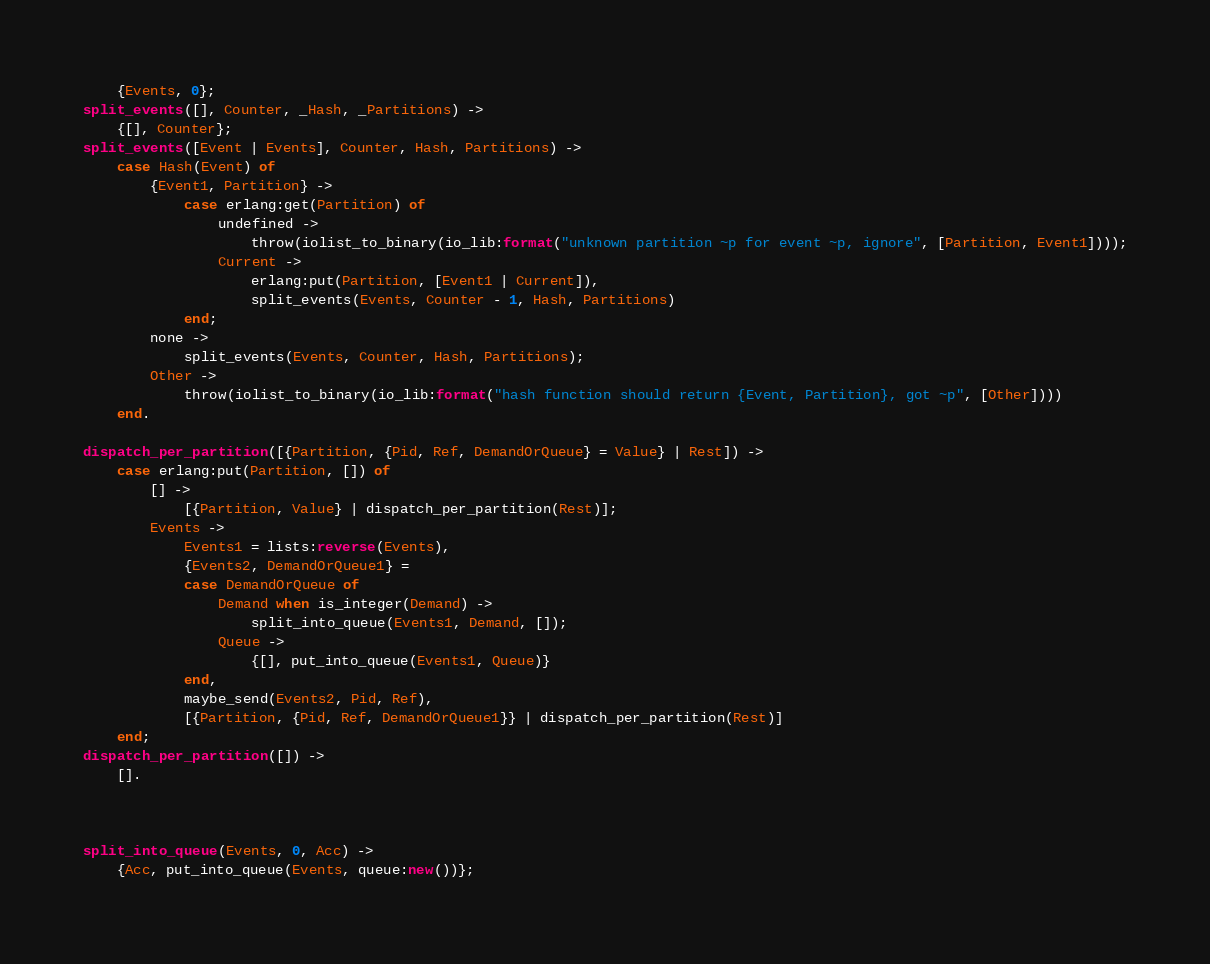Convert code to text. <code><loc_0><loc_0><loc_500><loc_500><_Erlang_>    {Events, 0};
split_events([], Counter, _Hash, _Partitions) ->
    {[], Counter};
split_events([Event | Events], Counter, Hash, Partitions) ->
    case Hash(Event) of
        {Event1, Partition} ->
            case erlang:get(Partition) of
                undefined ->
                    throw(iolist_to_binary(io_lib:format("unknown partition ~p for event ~p, ignore", [Partition, Event1])));
                Current ->
                    erlang:put(Partition, [Event1 | Current]),
                    split_events(Events, Counter - 1, Hash, Partitions)
            end;
        none ->
            split_events(Events, Counter, Hash, Partitions);
        Other ->
            throw(iolist_to_binary(io_lib:format("hash function should return {Event, Partition}, got ~p", [Other])))
    end.

dispatch_per_partition([{Partition, {Pid, Ref, DemandOrQueue} = Value} | Rest]) ->
    case erlang:put(Partition, []) of
        [] ->
            [{Partition, Value} | dispatch_per_partition(Rest)];
        Events ->
            Events1 = lists:reverse(Events),
            {Events2, DemandOrQueue1} =
            case DemandOrQueue of
                Demand when is_integer(Demand) ->
                    split_into_queue(Events1, Demand, []);
                Queue ->
                    {[], put_into_queue(Events1, Queue)}
            end,
            maybe_send(Events2, Pid, Ref),
            [{Partition, {Pid, Ref, DemandOrQueue1}} | dispatch_per_partition(Rest)]
    end;
dispatch_per_partition([]) ->
    [].



split_into_queue(Events, 0, Acc) ->
    {Acc, put_into_queue(Events, queue:new())};</code> 